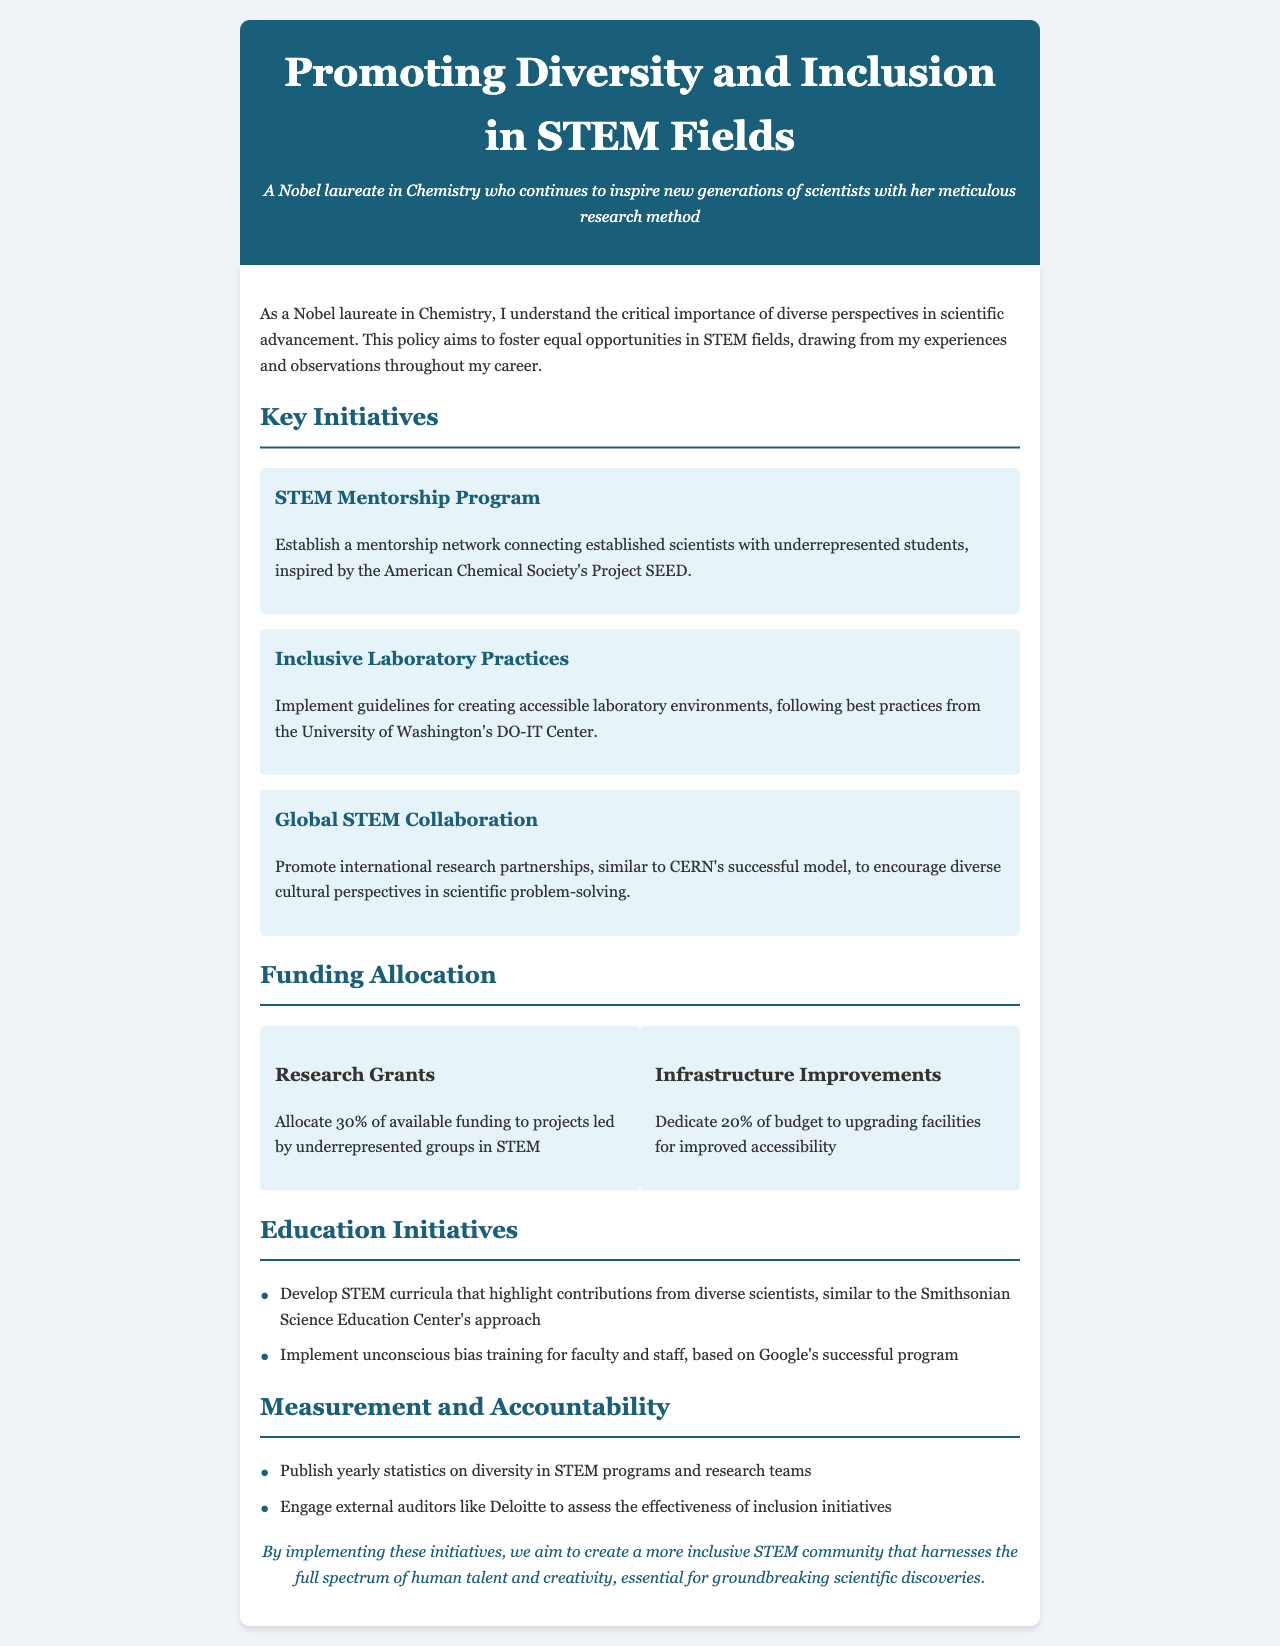What is the title of the document? The title is prominently displayed at the top of the document and is "Promoting Diversity and Inclusion in STEM Fields."
Answer: Promoting Diversity and Inclusion in STEM Fields Who is the persona of the document? The persona is described in the header section as a Nobel laureate in Chemistry who inspires new generations of scientists.
Answer: A Nobel laureate in Chemistry What percentage of funding is allocated to research grants? The document states that 30% of available funding is allocated to research grants.
Answer: 30% What initiative follows the STEM Mentorship Program? The next initiative listed after the STEM Mentorship Program is "Inclusive Laboratory Practices."
Answer: Inclusive Laboratory Practices Which organization inspired the STEM Mentorship Program? The STEM Mentorship Program is inspired by the American Chemical Society's Project SEED.
Answer: American Chemical Society's Project SEED What is implemented for improving accessibility? The document mentions that 20% of the budget is dedicated to upgrading facilities for improved accessibility.
Answer: Upgrading facilities How often are statistics on diversity in STEM programs published? The document mentions that yearly statistics on diversity are published.
Answer: Yearly What is the main goal of the initiatives mentioned? The primary aim is to create a more inclusive STEM community that harnesses diverse talent for scientific discoveries.
Answer: Create a more inclusive STEM community What type of training is suggested for faculty and staff? The document specifies the implementation of unconscious bias training for faculty and staff.
Answer: Unconscious bias training Who is suggested to assess the effectiveness of inclusion initiatives? External auditors like Deloitte are suggested to assess the effectiveness of inclusion initiatives.
Answer: Deloitte 